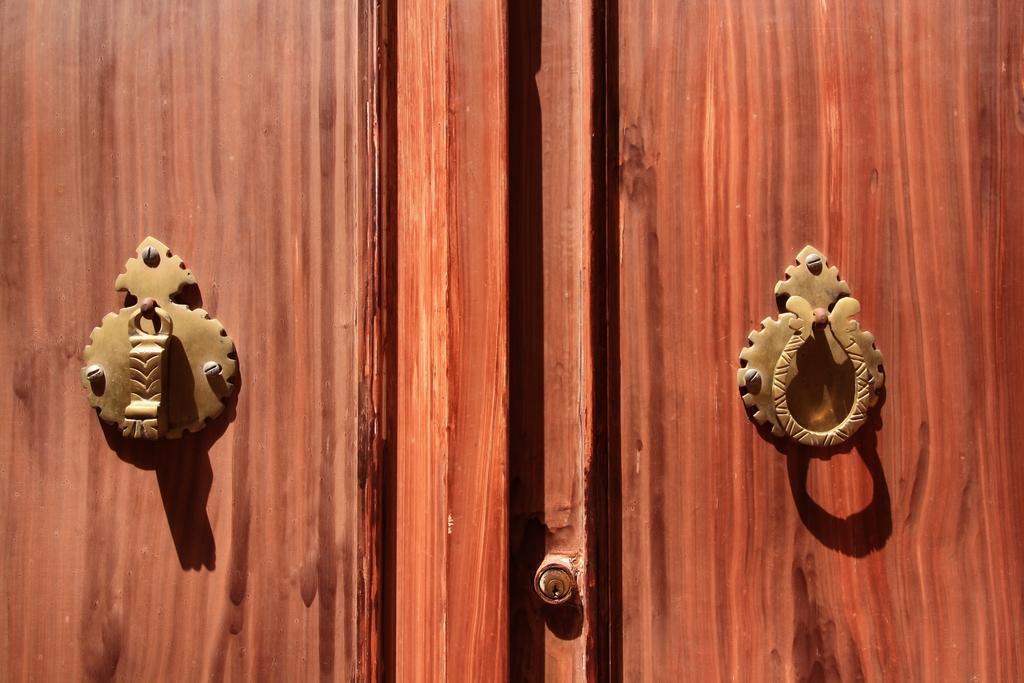How would you summarize this image in a sentence or two? In this image there is a wooden wall. There are metal knobs to the wall. 